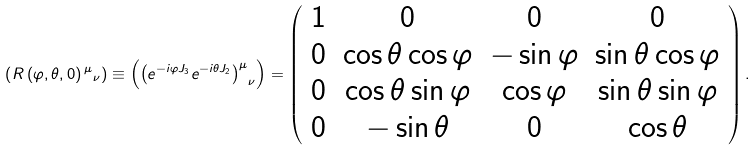Convert formula to latex. <formula><loc_0><loc_0><loc_500><loc_500>\left ( R \left ( \varphi , \theta , 0 \right ) { ^ { \mu } } _ { \nu } \right ) \equiv \left ( { \left ( e ^ { - i \varphi J _ { 3 } } e ^ { - i \theta J _ { 2 } } \right ) ^ { \mu } } _ { \nu } \right ) = \left ( \begin{array} { c c c c } 1 & 0 & 0 & 0 \\ 0 & \cos \theta \cos \varphi & - \sin \varphi & \sin \theta \cos \varphi \\ 0 & \cos \theta \sin \varphi & \cos \varphi & \sin \theta \sin \varphi \\ 0 & - \sin \theta & 0 & \cos \theta \end{array} \right ) .</formula> 